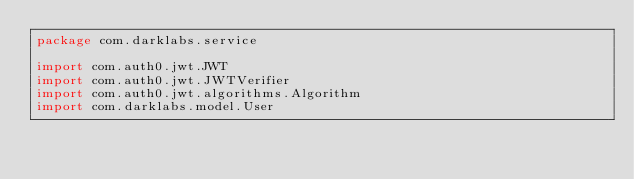<code> <loc_0><loc_0><loc_500><loc_500><_Kotlin_>package com.darklabs.service

import com.auth0.jwt.JWT
import com.auth0.jwt.JWTVerifier
import com.auth0.jwt.algorithms.Algorithm
import com.darklabs.model.User</code> 